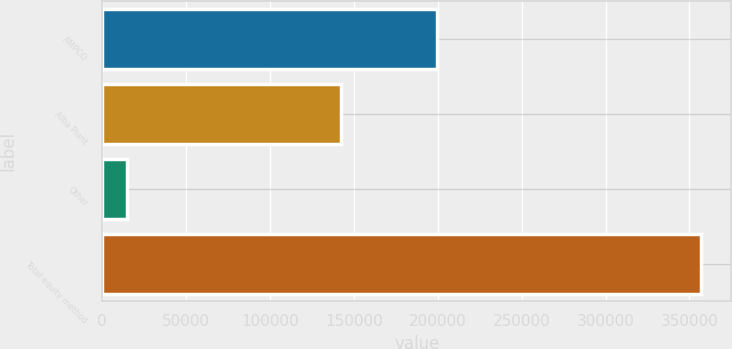<chart> <loc_0><loc_0><loc_500><loc_500><bar_chart><fcel>AMPCO<fcel>Alba Plant<fcel>Other<fcel>Total equity method<nl><fcel>199605<fcel>142540<fcel>14984<fcel>357129<nl></chart> 